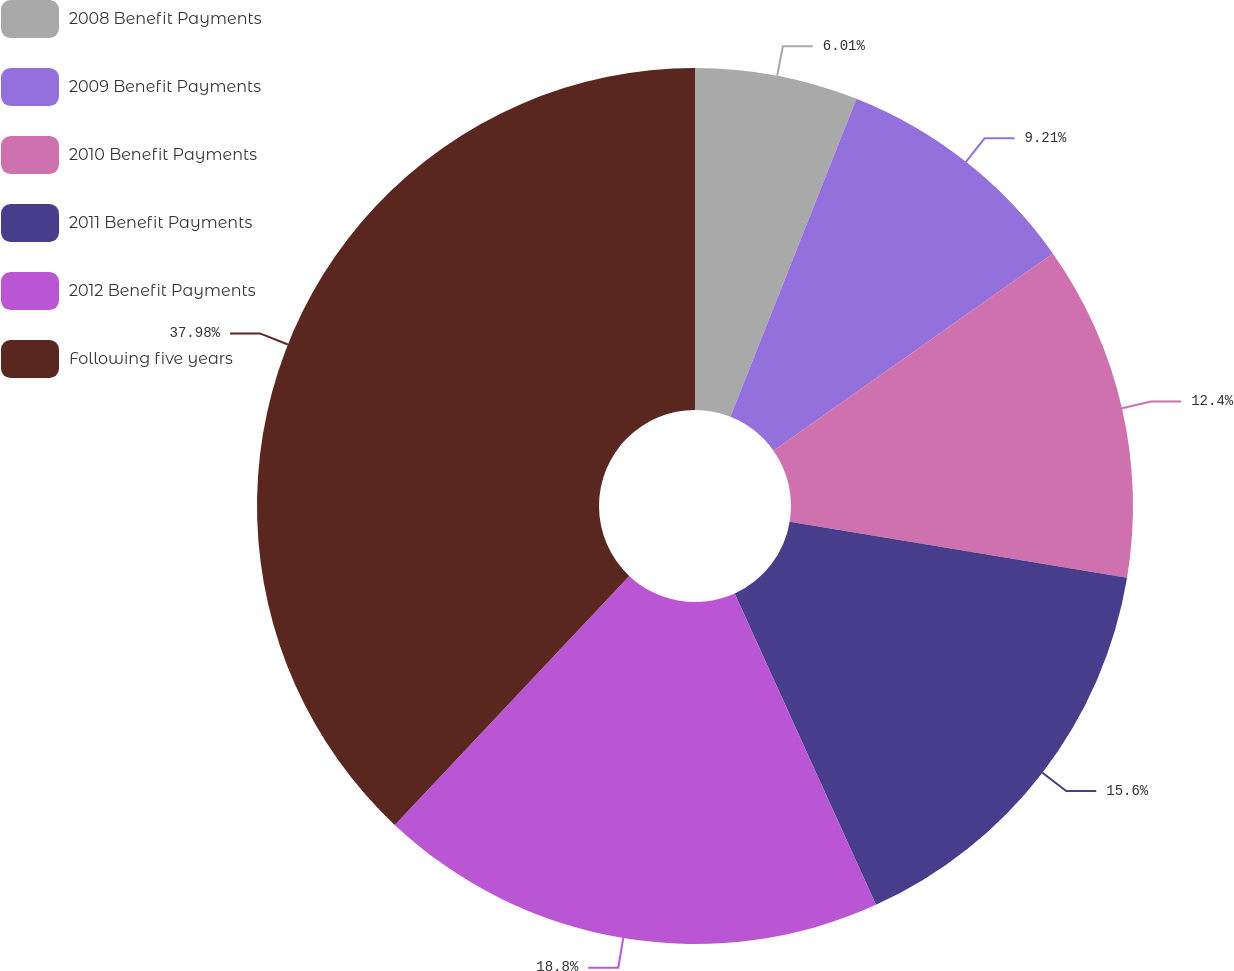Convert chart to OTSL. <chart><loc_0><loc_0><loc_500><loc_500><pie_chart><fcel>2008 Benefit Payments<fcel>2009 Benefit Payments<fcel>2010 Benefit Payments<fcel>2011 Benefit Payments<fcel>2012 Benefit Payments<fcel>Following five years<nl><fcel>6.01%<fcel>9.21%<fcel>12.4%<fcel>15.6%<fcel>18.8%<fcel>37.98%<nl></chart> 